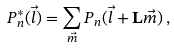<formula> <loc_0><loc_0><loc_500><loc_500>P _ { n } ^ { * } ( \vec { l } ) = \sum _ { \vec { m } } P _ { n } ( \vec { l } + \mathbf L \vec { m } ) \, ,</formula> 